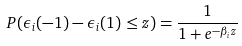<formula> <loc_0><loc_0><loc_500><loc_500>P ( \epsilon _ { i } ( - 1 ) - \epsilon _ { i } ( 1 ) \leq z ) = \frac { 1 } { 1 + e ^ { - \beta _ { i } z } }</formula> 